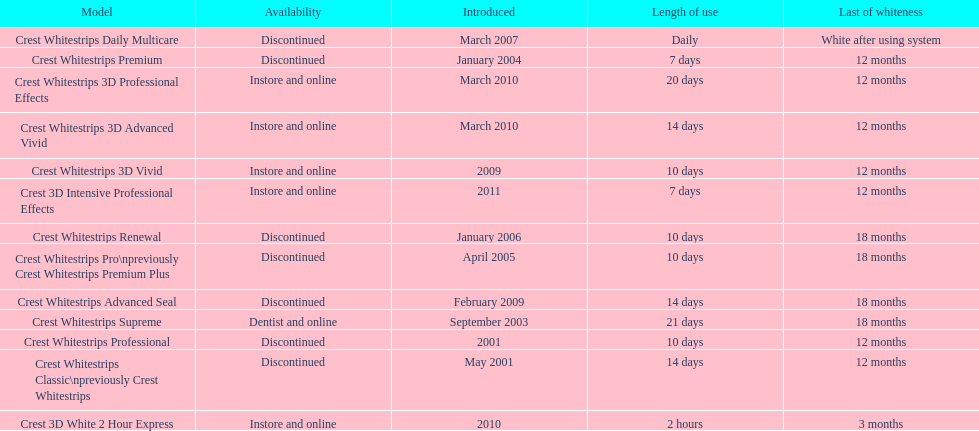Which model has the highest 'length of use' to 'last of whiteness' ratio? Crest Whitestrips Supreme. 